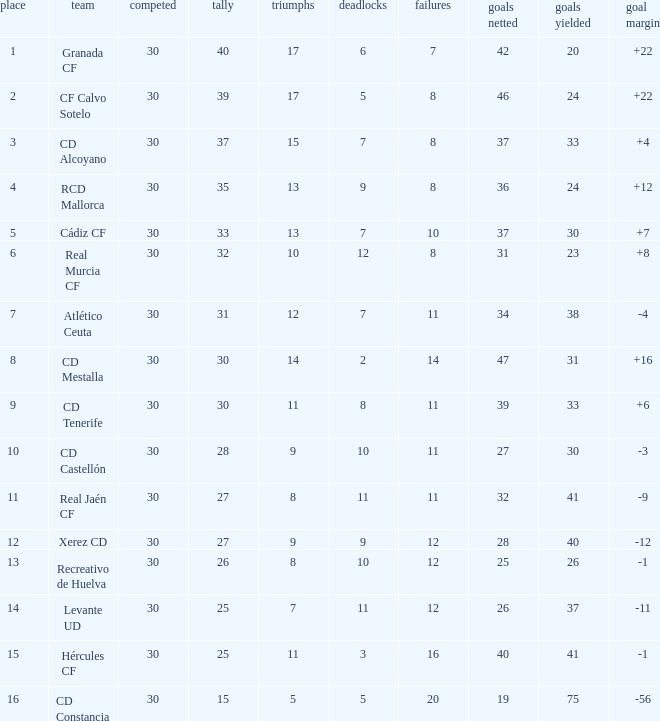How many Draws have 30 Points, and less than 33 Goals against? 1.0. 